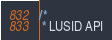<code> <loc_0><loc_0><loc_500><loc_500><_Java_>/*
 * LUSID API</code> 